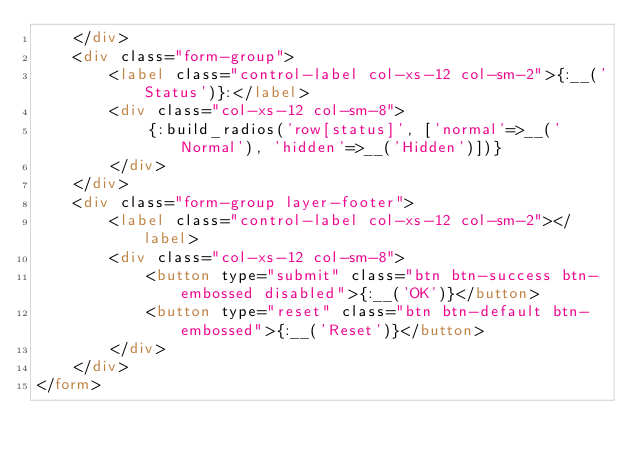<code> <loc_0><loc_0><loc_500><loc_500><_HTML_>    </div>
    <div class="form-group">
        <label class="control-label col-xs-12 col-sm-2">{:__('Status')}:</label>
        <div class="col-xs-12 col-sm-8">
            {:build_radios('row[status]', ['normal'=>__('Normal'), 'hidden'=>__('Hidden')])}
        </div>
    </div>
    <div class="form-group layer-footer">
        <label class="control-label col-xs-12 col-sm-2"></label>
        <div class="col-xs-12 col-sm-8">
            <button type="submit" class="btn btn-success btn-embossed disabled">{:__('OK')}</button>
            <button type="reset" class="btn btn-default btn-embossed">{:__('Reset')}</button>
        </div>
    </div>
</form>
</code> 